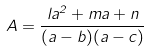<formula> <loc_0><loc_0><loc_500><loc_500>A = \frac { l a ^ { 2 } + m a + n } { ( a - b ) ( a - c ) }</formula> 